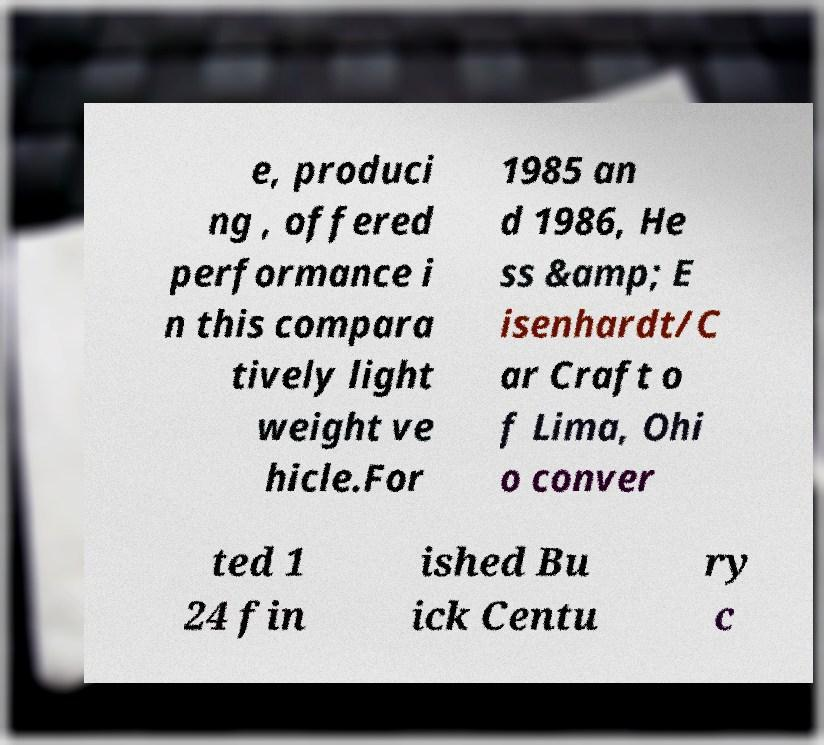Please identify and transcribe the text found in this image. e, produci ng , offered performance i n this compara tively light weight ve hicle.For 1985 an d 1986, He ss &amp; E isenhardt/C ar Craft o f Lima, Ohi o conver ted 1 24 fin ished Bu ick Centu ry c 